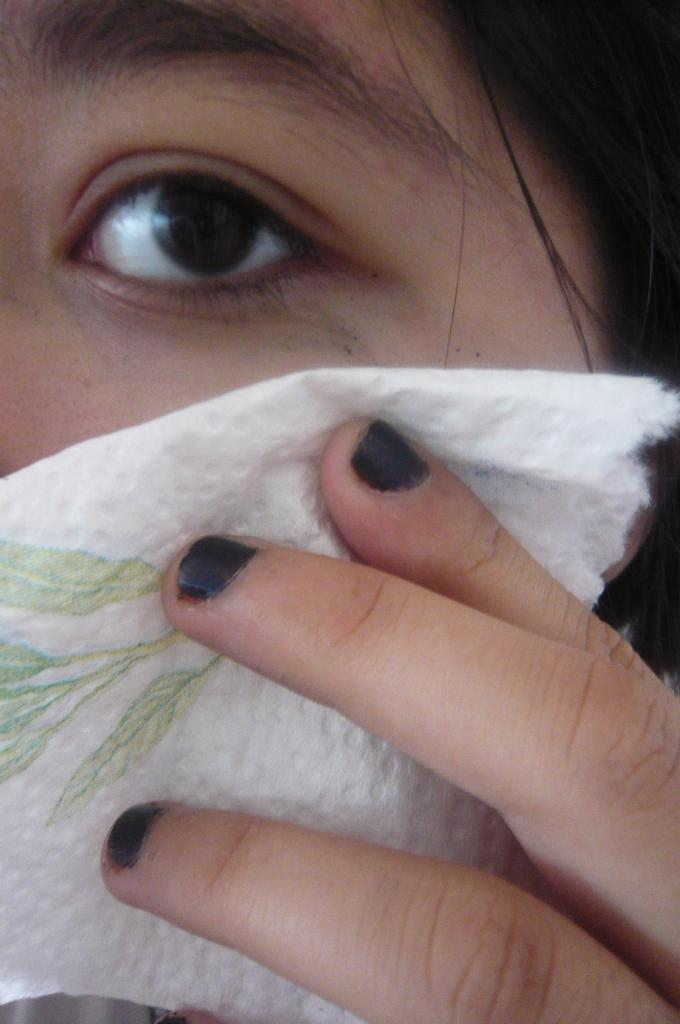Who is present in the image? There is a person in the image. What is the person holding in the image? The person is holding a tissue paper. What is depicted on the tissue paper? There is a painting on the tissue paper. How many pins are attached to the person's clothing in the image? There is no mention of pins or any attachment to the person's clothing in the image. 